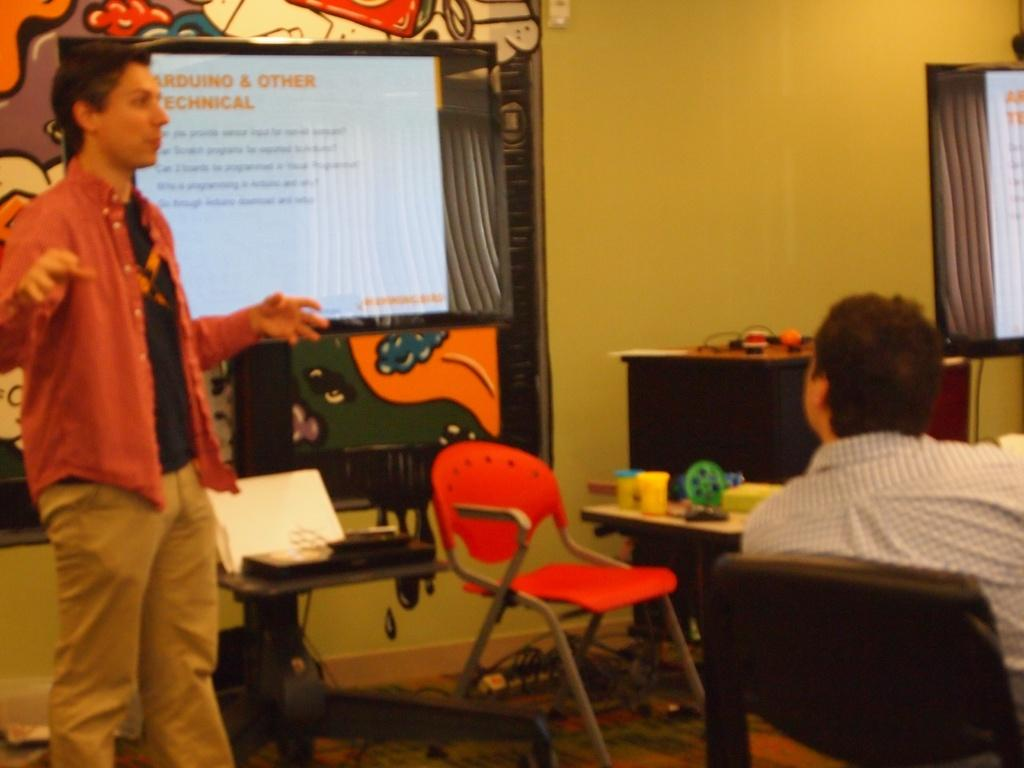What is happening on the left side of the image? There is a person standing on the left side of the image. What is the person on the left side of the image doing? The person is explaining something. Can you describe the position of the other person in the image? There is a person sitting on a chair in the image. What type of crack can be seen in the image? There is no crack present in the image. What curve is visible in the image? There is no curve visible in the image. 